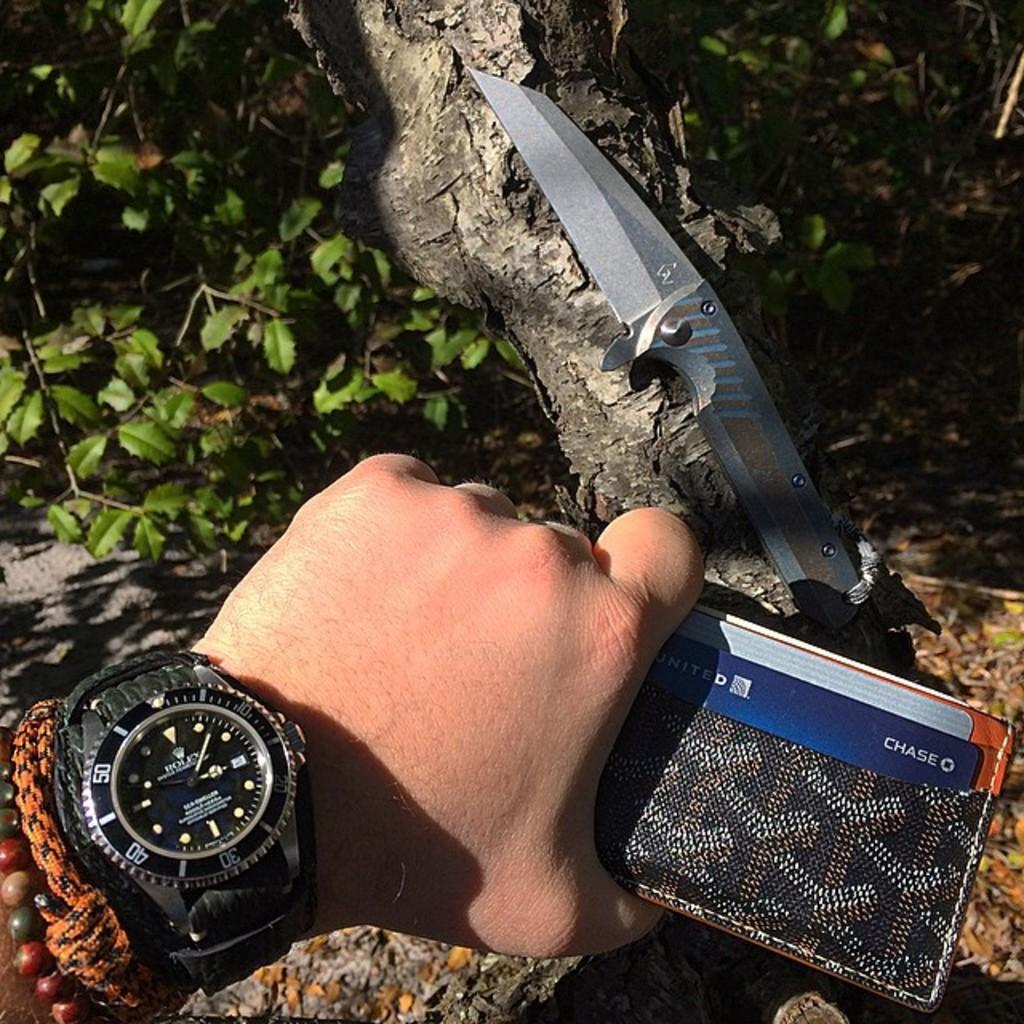<image>
Write a terse but informative summary of the picture. A man holding a wallet is wearing a Rolex watch. 